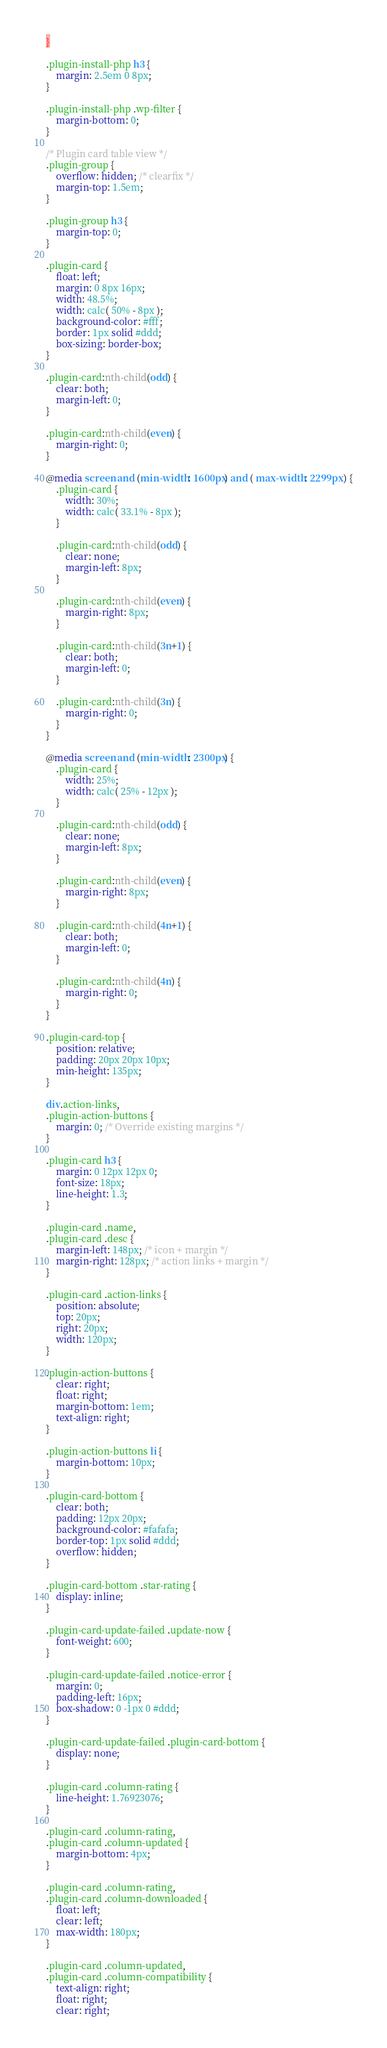Convert code to text. <code><loc_0><loc_0><loc_500><loc_500><_CSS_>}

.plugin-install-php h3 {
	margin: 2.5em 0 8px;
}

.plugin-install-php .wp-filter {
	margin-bottom: 0;
}

/* Plugin card table view */
.plugin-group {
	overflow: hidden; /* clearfix */
	margin-top: 1.5em;
}

.plugin-group h3 {
	margin-top: 0;
}

.plugin-card {
	float: left;
	margin: 0 8px 16px;
	width: 48.5%;
	width: calc( 50% - 8px );
	background-color: #fff;
	border: 1px solid #ddd;
	box-sizing: border-box;
}

.plugin-card:nth-child(odd) {
	clear: both;
	margin-left: 0;
}

.plugin-card:nth-child(even) {
	margin-right: 0;
}

@media screen and (min-width: 1600px) and ( max-width: 2299px ) {
	.plugin-card {
		width: 30%;
		width: calc( 33.1% - 8px );
	}

	.plugin-card:nth-child(odd) {
		clear: none;
		margin-left: 8px;
	}

	.plugin-card:nth-child(even) {
		margin-right: 8px;
	}

	.plugin-card:nth-child(3n+1) {
		clear: both;
		margin-left: 0;
	}

	.plugin-card:nth-child(3n) {
		margin-right: 0;
	}
}

@media screen and (min-width: 2300px) {
	.plugin-card {
		width: 25%;
		width: calc( 25% - 12px );
	}

	.plugin-card:nth-child(odd) {
		clear: none;
		margin-left: 8px;
	}

	.plugin-card:nth-child(even) {
		margin-right: 8px;
	}

	.plugin-card:nth-child(4n+1) {
		clear: both;
		margin-left: 0;
	}

	.plugin-card:nth-child(4n) {
		margin-right: 0;
	}
}

.plugin-card-top {
	position: relative;
	padding: 20px 20px 10px;
	min-height: 135px;
}

div.action-links,
.plugin-action-buttons {
	margin: 0; /* Override existing margins */
}

.plugin-card h3 {
	margin: 0 12px 12px 0;
	font-size: 18px;
	line-height: 1.3;
}

.plugin-card .name,
.plugin-card .desc {
	margin-left: 148px; /* icon + margin */
	margin-right: 128px; /* action links + margin */
}

.plugin-card .action-links {
	position: absolute;
	top: 20px;
	right: 20px;
	width: 120px;
}

.plugin-action-buttons {
	clear: right;
	float: right;
	margin-bottom: 1em;
	text-align: right;
}

.plugin-action-buttons li {
	margin-bottom: 10px;
}

.plugin-card-bottom {
	clear: both;
	padding: 12px 20px;
	background-color: #fafafa;
	border-top: 1px solid #ddd;
	overflow: hidden;
}

.plugin-card-bottom .star-rating {
	display: inline;
}

.plugin-card-update-failed .update-now {
	font-weight: 600;
}

.plugin-card-update-failed .notice-error {
	margin: 0;
	padding-left: 16px;
	box-shadow: 0 -1px 0 #ddd;
}

.plugin-card-update-failed .plugin-card-bottom {
	display: none;
}

.plugin-card .column-rating {
	line-height: 1.76923076;
}

.plugin-card .column-rating,
.plugin-card .column-updated {
	margin-bottom: 4px;
}

.plugin-card .column-rating,
.plugin-card .column-downloaded {
	float: left;
	clear: left;
	max-width: 180px;
}

.plugin-card .column-updated,
.plugin-card .column-compatibility {
	text-align: right;
	float: right;
	clear: right;</code> 